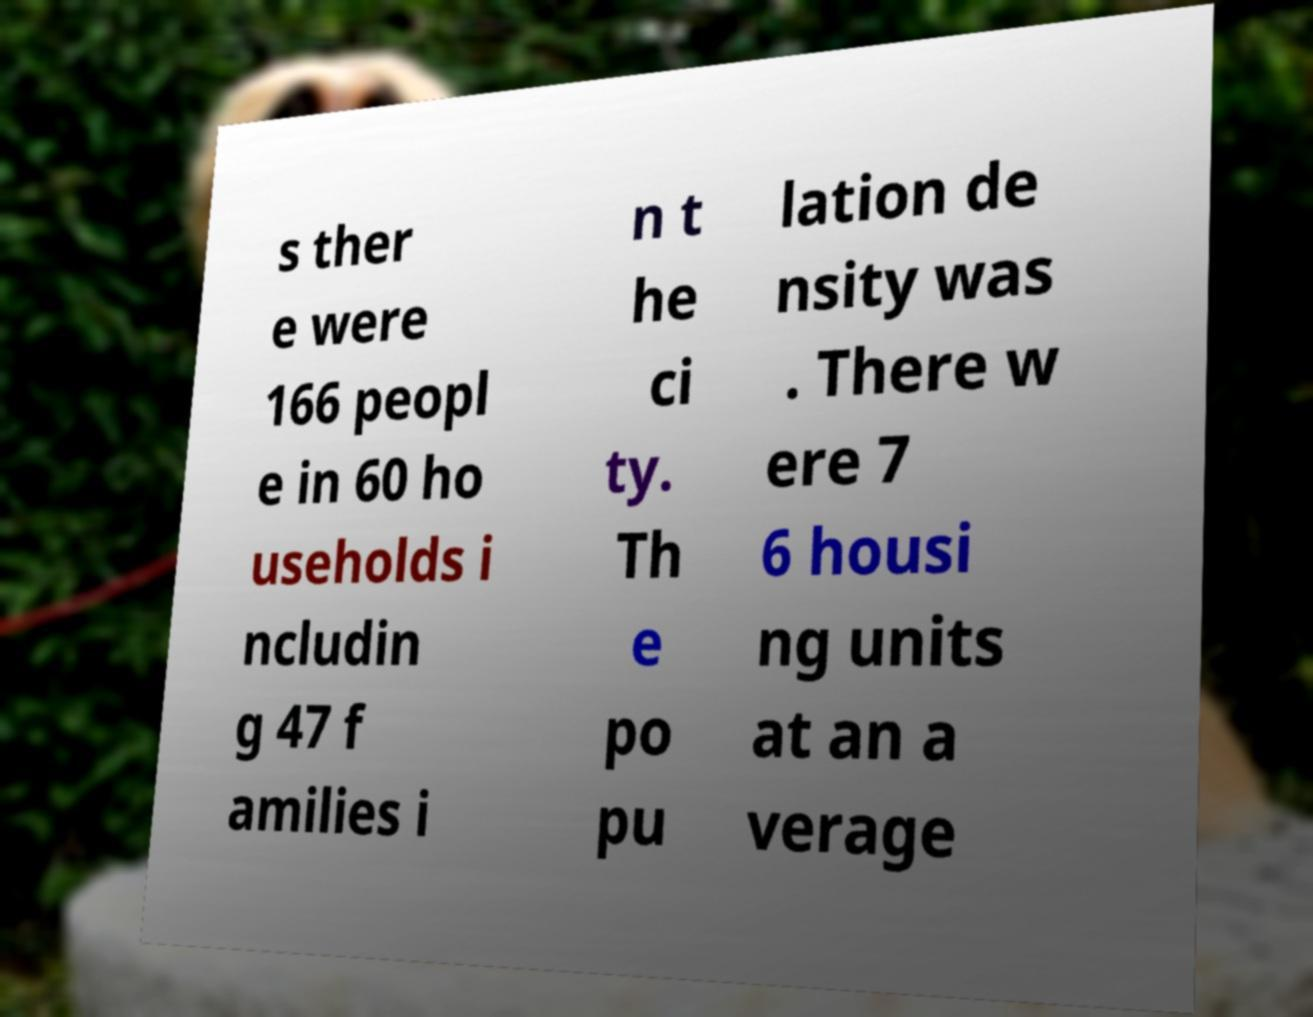Could you extract and type out the text from this image? s ther e were 166 peopl e in 60 ho useholds i ncludin g 47 f amilies i n t he ci ty. Th e po pu lation de nsity was . There w ere 7 6 housi ng units at an a verage 